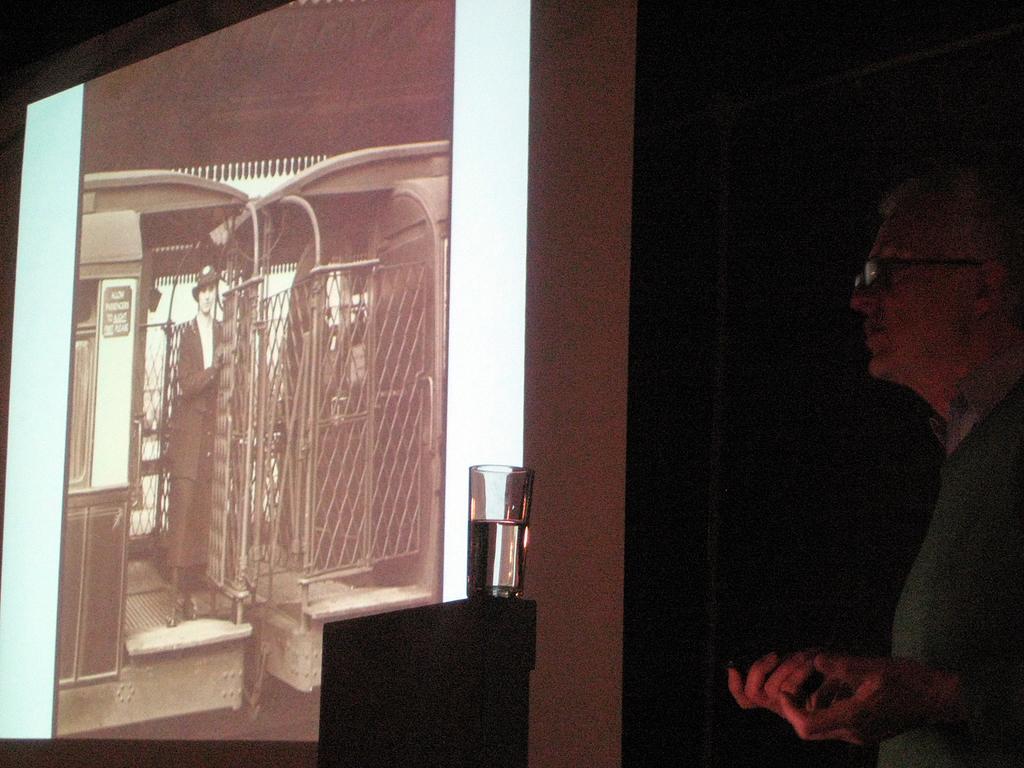In one or two sentences, can you explain what this image depicts? In this image I can see a person on the right side , in the middle I can see screen , in the screen I can see person image , fence, in front of screen there is a glass contain water kept on table. 